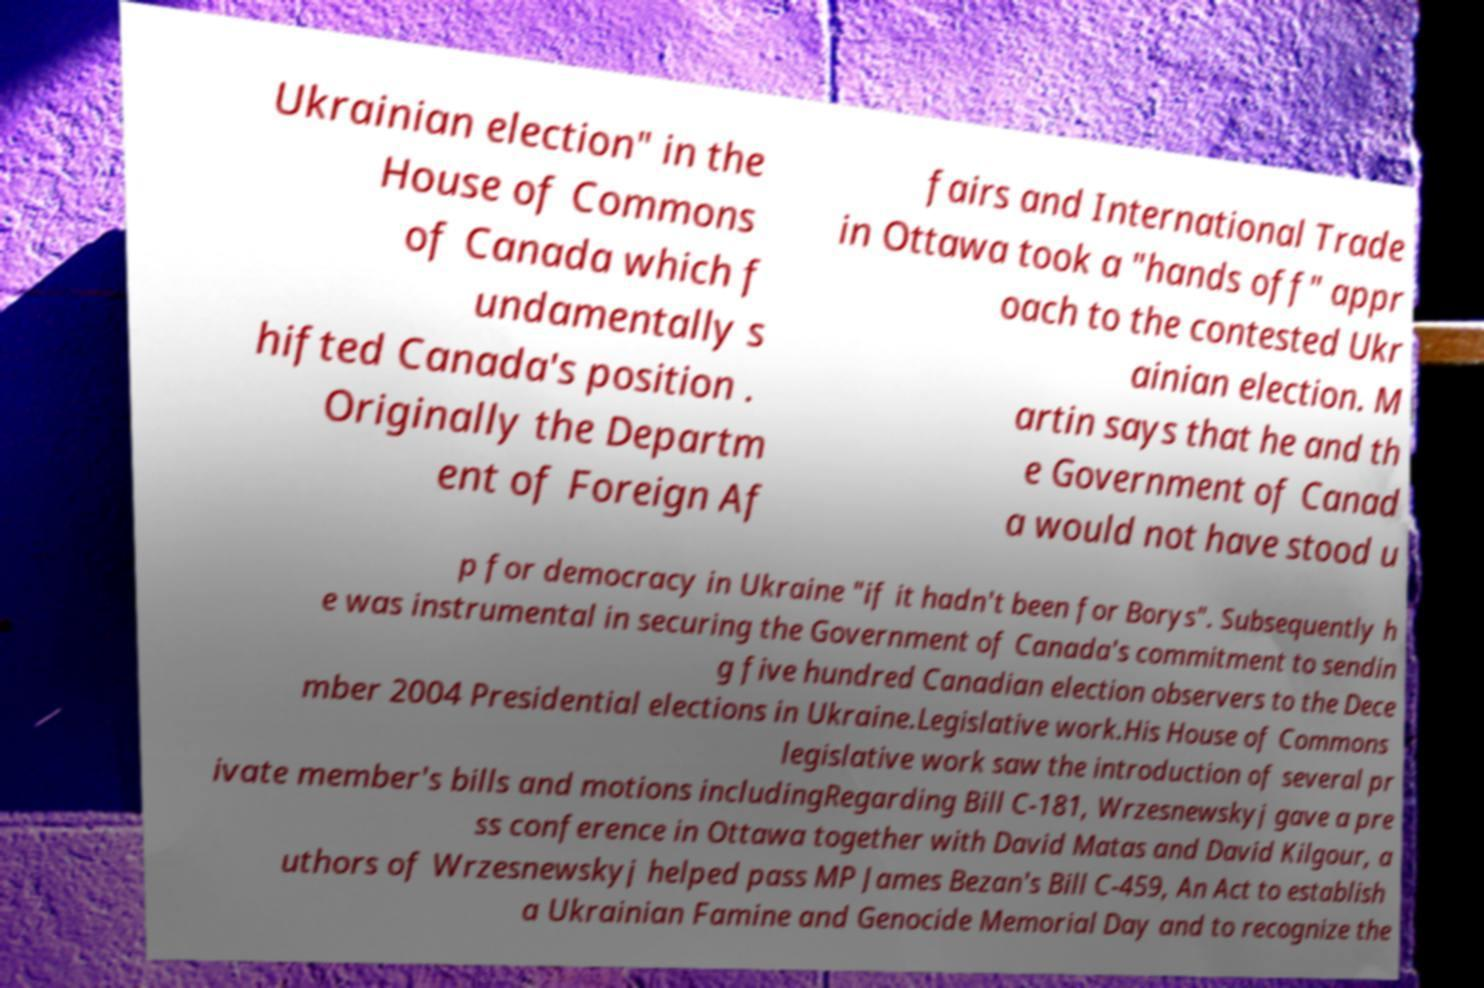Please identify and transcribe the text found in this image. Ukrainian election" in the House of Commons of Canada which f undamentally s hifted Canada's position . Originally the Departm ent of Foreign Af fairs and International Trade in Ottawa took a "hands off" appr oach to the contested Ukr ainian election. M artin says that he and th e Government of Canad a would not have stood u p for democracy in Ukraine "if it hadn't been for Borys". Subsequently h e was instrumental in securing the Government of Canada's commitment to sendin g five hundred Canadian election observers to the Dece mber 2004 Presidential elections in Ukraine.Legislative work.His House of Commons legislative work saw the introduction of several pr ivate member's bills and motions includingRegarding Bill C-181, Wrzesnewskyj gave a pre ss conference in Ottawa together with David Matas and David Kilgour, a uthors of Wrzesnewskyj helped pass MP James Bezan's Bill C-459, An Act to establish a Ukrainian Famine and Genocide Memorial Day and to recognize the 